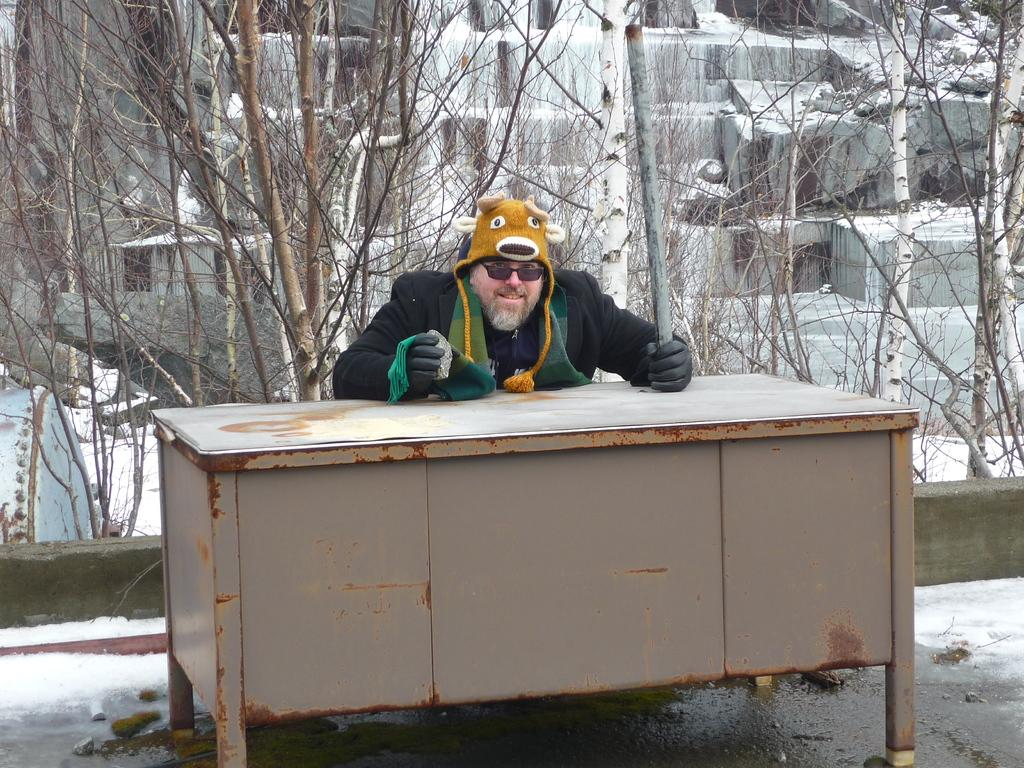What can be seen in the image? There is a person in the image. Can you describe the person's clothing? The person is wearing a jacket, glasses, a cap, and gloves. What is the person holding in his hands? The person is holding a stone and a rod in his hands. What is in front of the person? There is a table in front of the person. What can be seen behind the person? There are dry trees behind the person. What type of jar can be seen on the bed in the image? There is no bed or jar present in the image; it features a person holding a stone and a rod, with a table in front of them and dry trees behind them. 